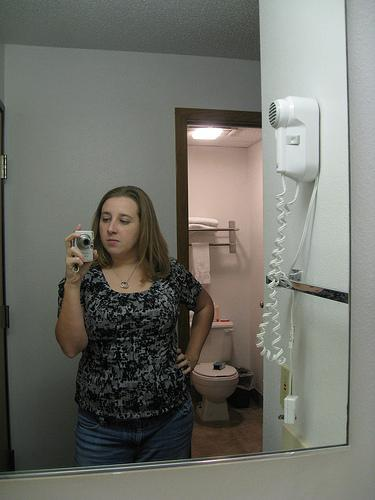Question: what is the woman wearing?
Choices:
A. Skirt and blouse.
B. Dress.
C. Jeans and a shirt.
D. Shorts and t-shirt.
Answer with the letter. Answer: C 